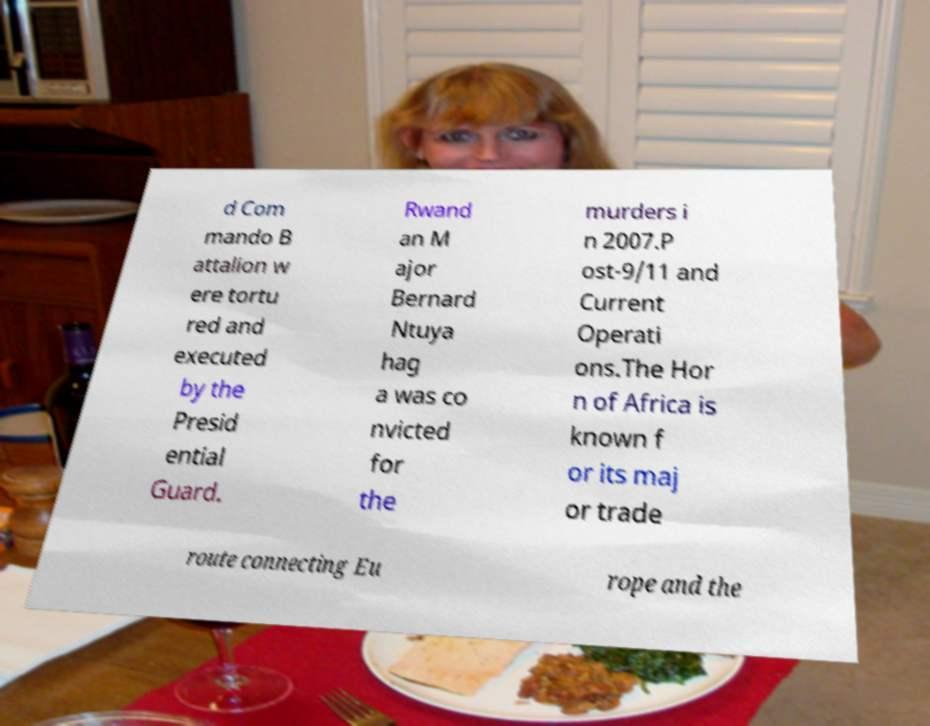Can you accurately transcribe the text from the provided image for me? d Com mando B attalion w ere tortu red and executed by the Presid ential Guard. Rwand an M ajor Bernard Ntuya hag a was co nvicted for the murders i n 2007.P ost-9/11 and Current Operati ons.The Hor n of Africa is known f or its maj or trade route connecting Eu rope and the 